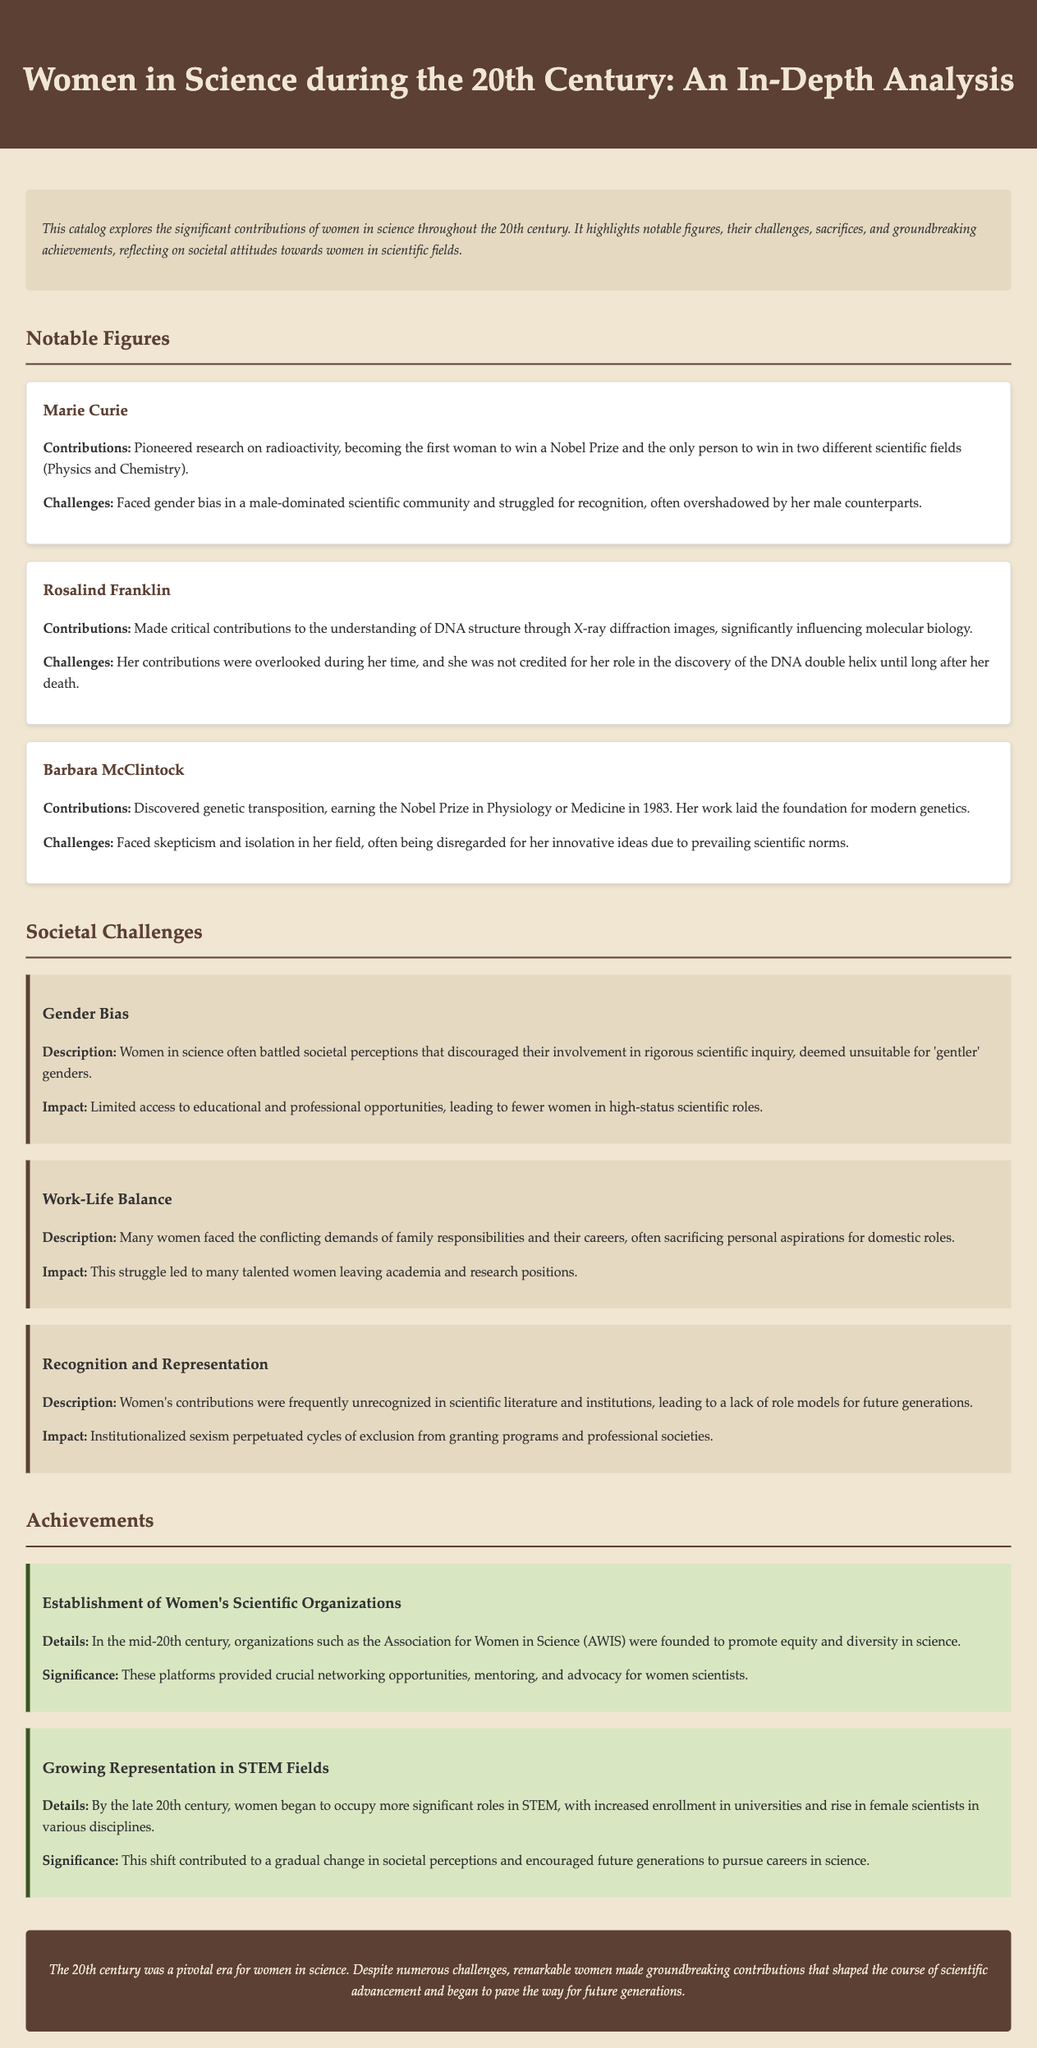What major scientific field did Marie Curie win a Nobel Prize in? Marie Curie won Nobel Prizes in Physics and Chemistry, reflecting her significant contributions to radioactivity.
Answer: Physics and Chemistry Who made critical contributions to the understanding of DNA structure? Rosalind Franklin is noted for her key role in revealing the structure of DNA through X-ray diffraction.
Answer: Rosalind Franklin In what year did Barbara McClintock win the Nobel Prize in Physiology or Medicine? Barbara McClintock received the Nobel Prize in 1983 for her discovery of genetic transposition.
Answer: 1983 What societal challenge discouraged women's involvement in scientific inquiry? Gender bias was a prevalent issue that hindered women's participation in scientific fields.
Answer: Gender bias What organization was founded to promote equity for women in science? The Association for Women in Science (AWIS) was established as a significant platform to support women in science.
Answer: Association for Women in Science (AWIS) 